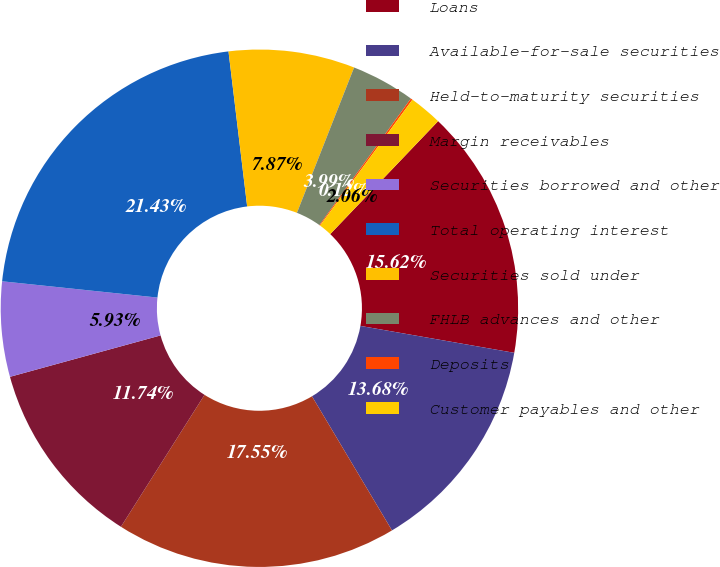Convert chart. <chart><loc_0><loc_0><loc_500><loc_500><pie_chart><fcel>Loans<fcel>Available-for-sale securities<fcel>Held-to-maturity securities<fcel>Margin receivables<fcel>Securities borrowed and other<fcel>Total operating interest<fcel>Securities sold under<fcel>FHLB advances and other<fcel>Deposits<fcel>Customer payables and other<nl><fcel>15.62%<fcel>13.68%<fcel>17.55%<fcel>11.74%<fcel>5.93%<fcel>21.43%<fcel>7.87%<fcel>3.99%<fcel>0.12%<fcel>2.06%<nl></chart> 